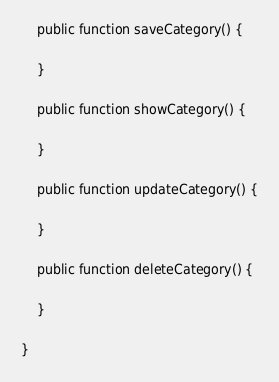<code> <loc_0><loc_0><loc_500><loc_500><_PHP_>
    public function saveCategory() {
        
    }

    public function showCategory() {
        
    }

    public function updateCategory() {
        
    }

    public function deleteCategory() {
        
    }

}
</code> 